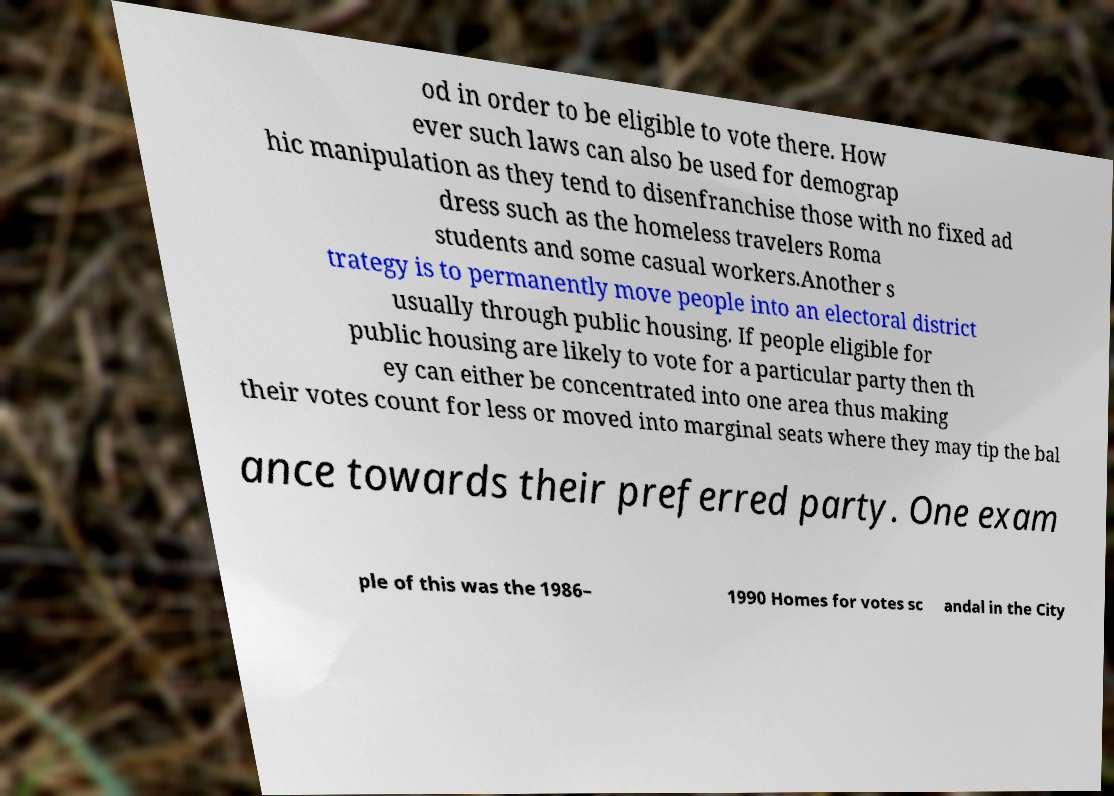Please read and relay the text visible in this image. What does it say? od in order to be eligible to vote there. How ever such laws can also be used for demograp hic manipulation as they tend to disenfranchise those with no fixed ad dress such as the homeless travelers Roma students and some casual workers.Another s trategy is to permanently move people into an electoral district usually through public housing. If people eligible for public housing are likely to vote for a particular party then th ey can either be concentrated into one area thus making their votes count for less or moved into marginal seats where they may tip the bal ance towards their preferred party. One exam ple of this was the 1986– 1990 Homes for votes sc andal in the City 